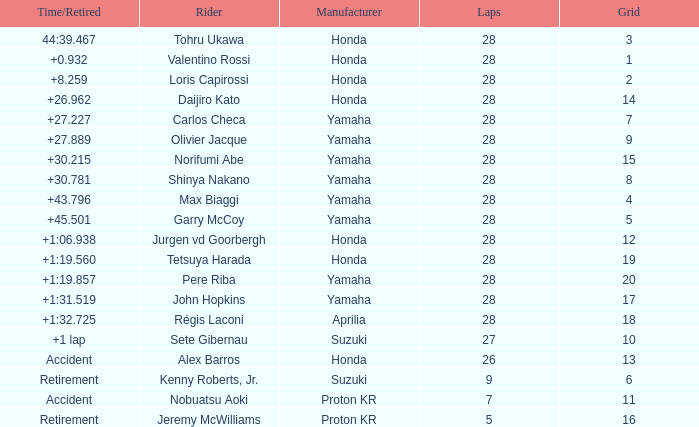How many laps were in grid 4? 28.0. 